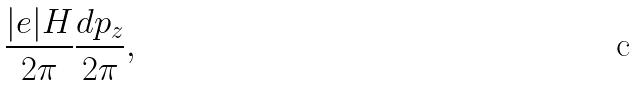<formula> <loc_0><loc_0><loc_500><loc_500>\frac { | e | H } { 2 \pi } \frac { d p _ { z } } { 2 \pi } ,</formula> 